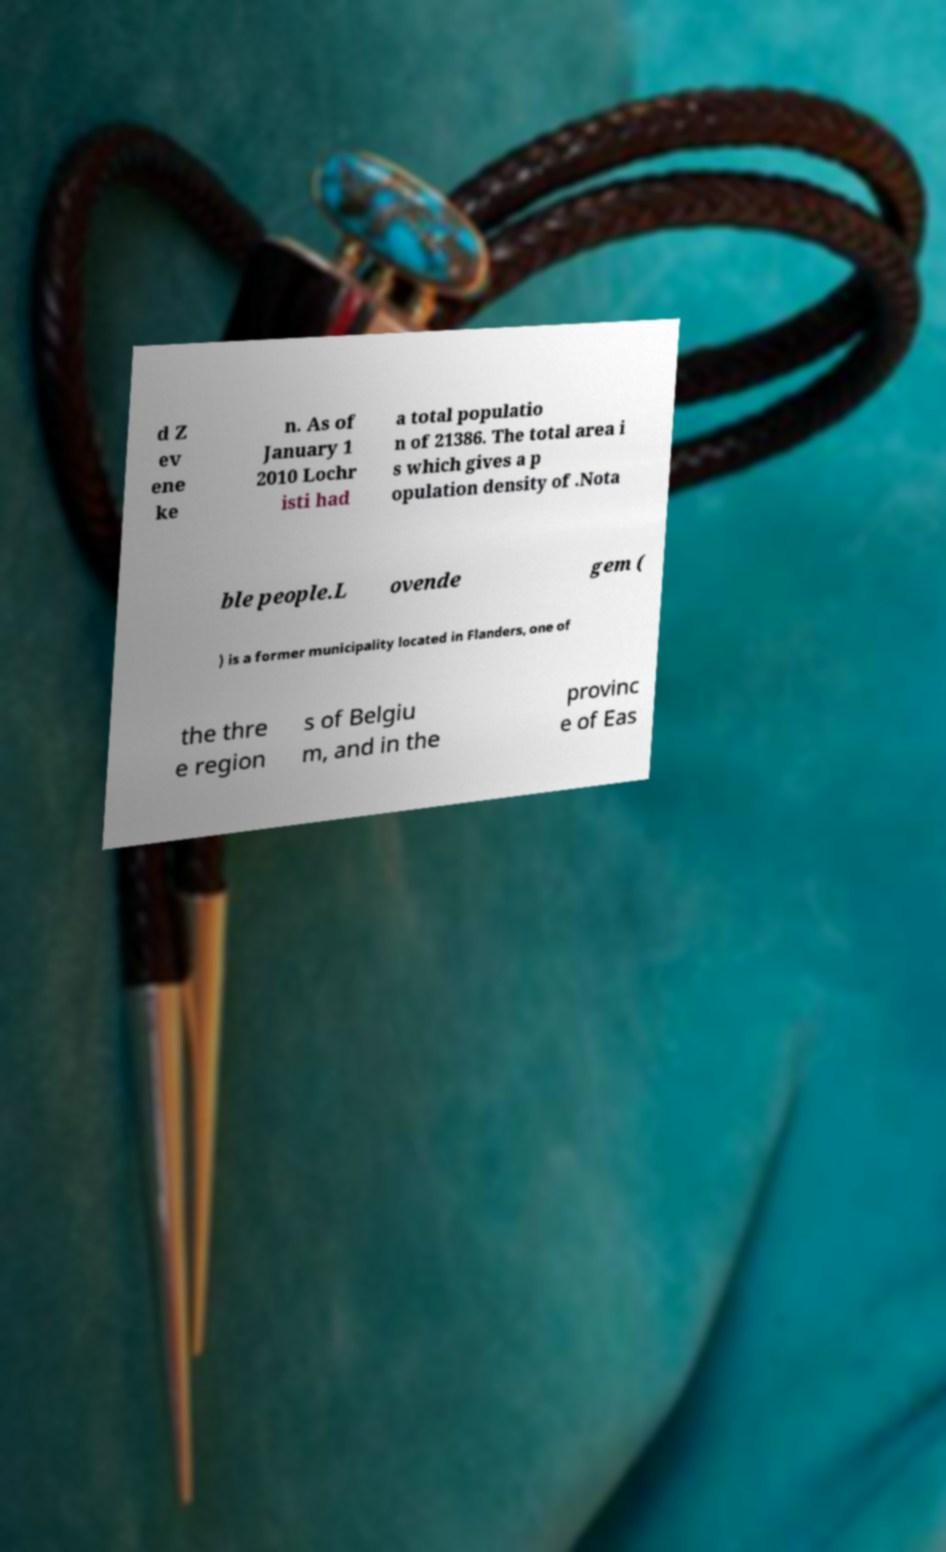What messages or text are displayed in this image? I need them in a readable, typed format. d Z ev ene ke n. As of January 1 2010 Lochr isti had a total populatio n of 21386. The total area i s which gives a p opulation density of .Nota ble people.L ovende gem ( ) is a former municipality located in Flanders, one of the thre e region s of Belgiu m, and in the provinc e of Eas 